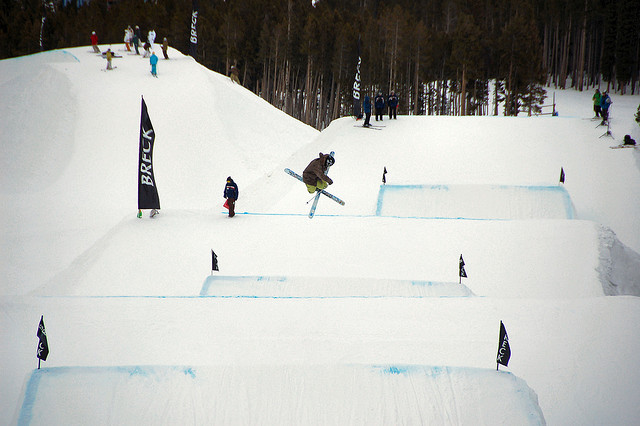Please identify all text content in this image. BRECK 